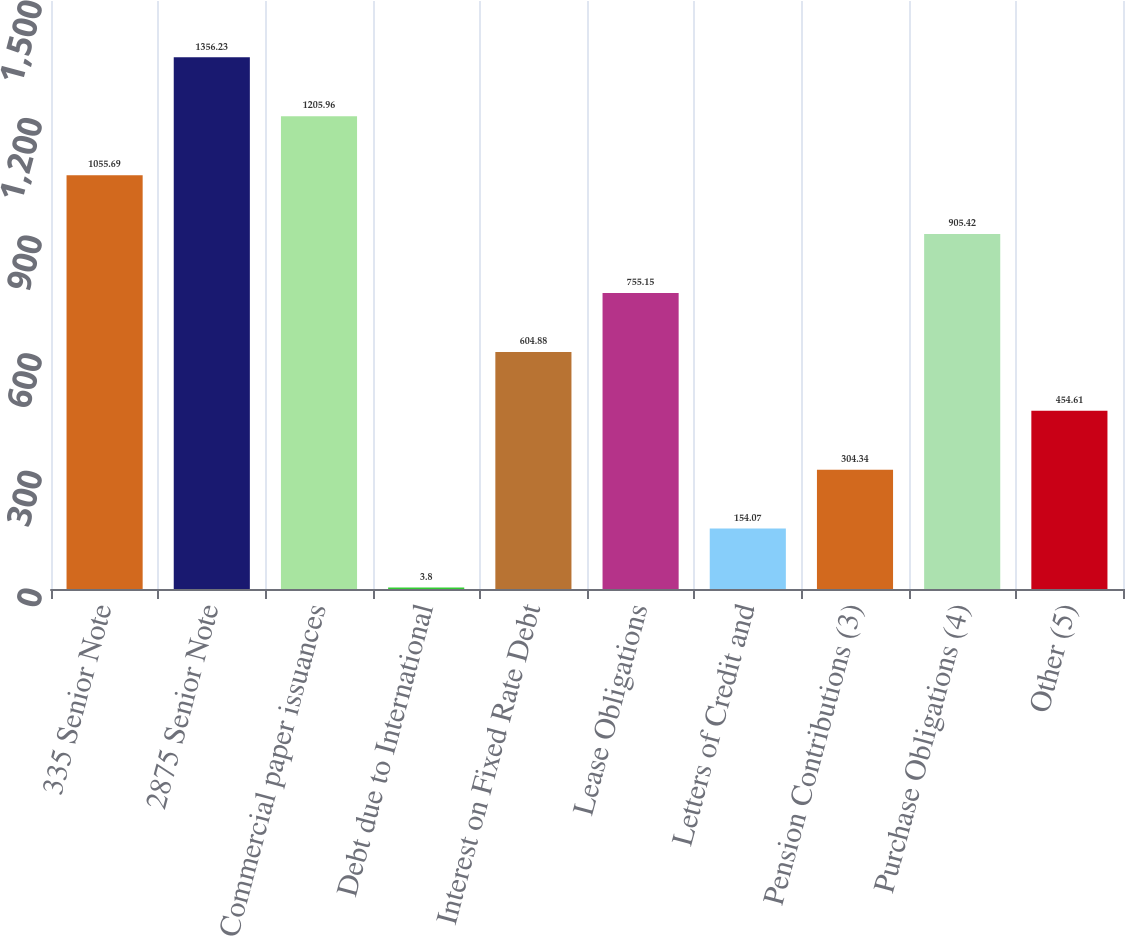<chart> <loc_0><loc_0><loc_500><loc_500><bar_chart><fcel>335 Senior Note<fcel>2875 Senior Note<fcel>Commercial paper issuances<fcel>Debt due to International<fcel>Interest on Fixed Rate Debt<fcel>Lease Obligations<fcel>Letters of Credit and<fcel>Pension Contributions (3)<fcel>Purchase Obligations (4)<fcel>Other (5)<nl><fcel>1055.69<fcel>1356.23<fcel>1205.96<fcel>3.8<fcel>604.88<fcel>755.15<fcel>154.07<fcel>304.34<fcel>905.42<fcel>454.61<nl></chart> 